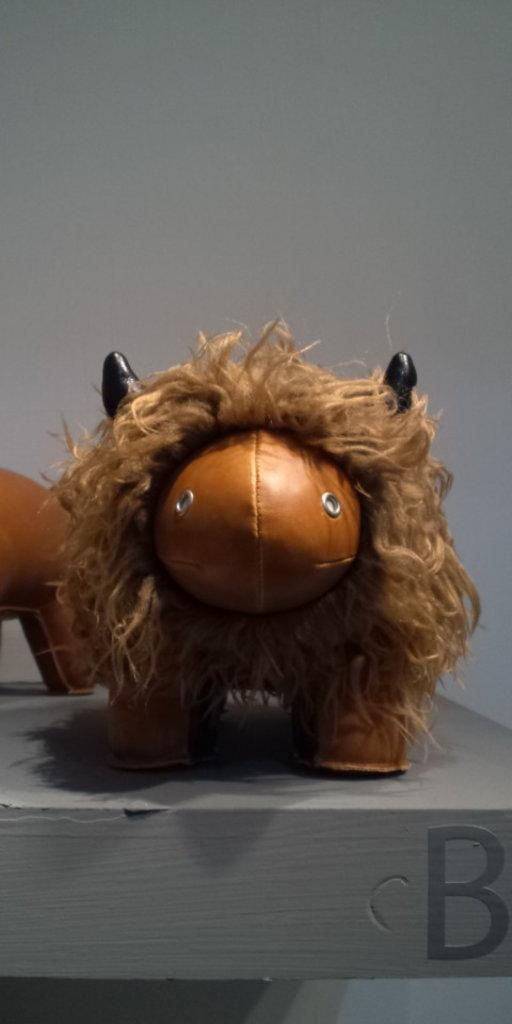How many toys can be seen in the image? There are two toys in the image. What is the toys resting on or attached to? The toys are on an object. What can be seen behind the toys? There is a wall behind the toys. What letter is written on the object the toys are on? The object has the letter "B" written on it. Can you see any insects crawling on the toys in the image? There are no insects visible in the image. Is there a railway track present in the image? There is no railway track present in the image. 